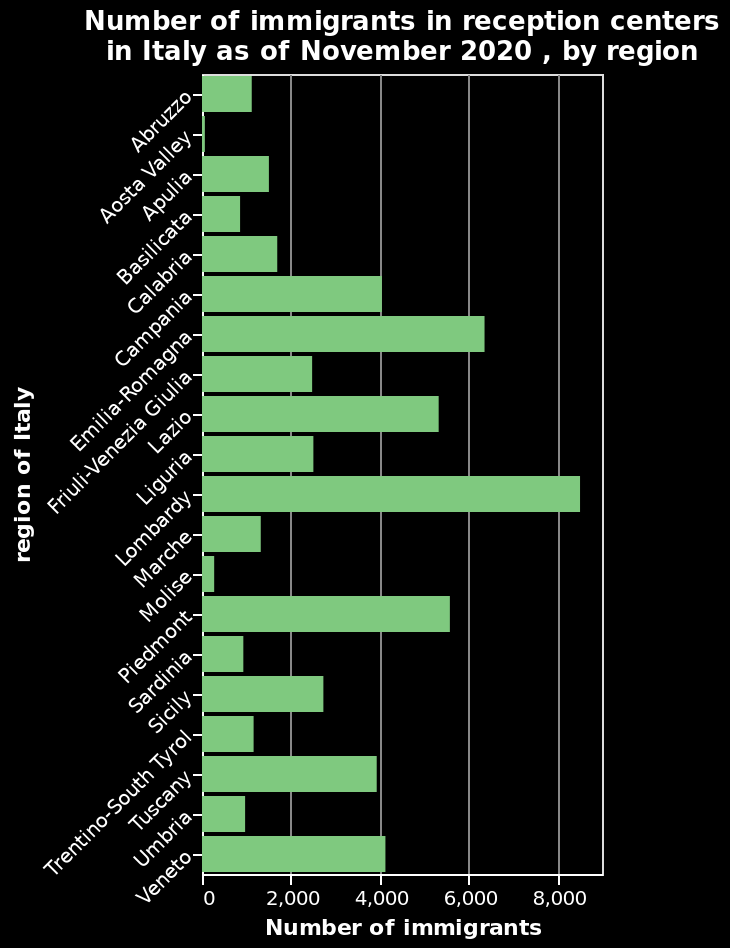<image>
What does each bar in the diagram represent? Each bar in the diagram represents the number of immigrants in reception centers for a specific region in Italy. Which other region, besides the Aosta Valley, has small amounts of immigrants in reception centres? Besides the Aosta Valley, Molise also has small amounts of immigrants in reception centres. What is the name of the bar diagram?  The bar diagram is named "Number of immigrants in reception centers in Italy as of November 2020, by region." 